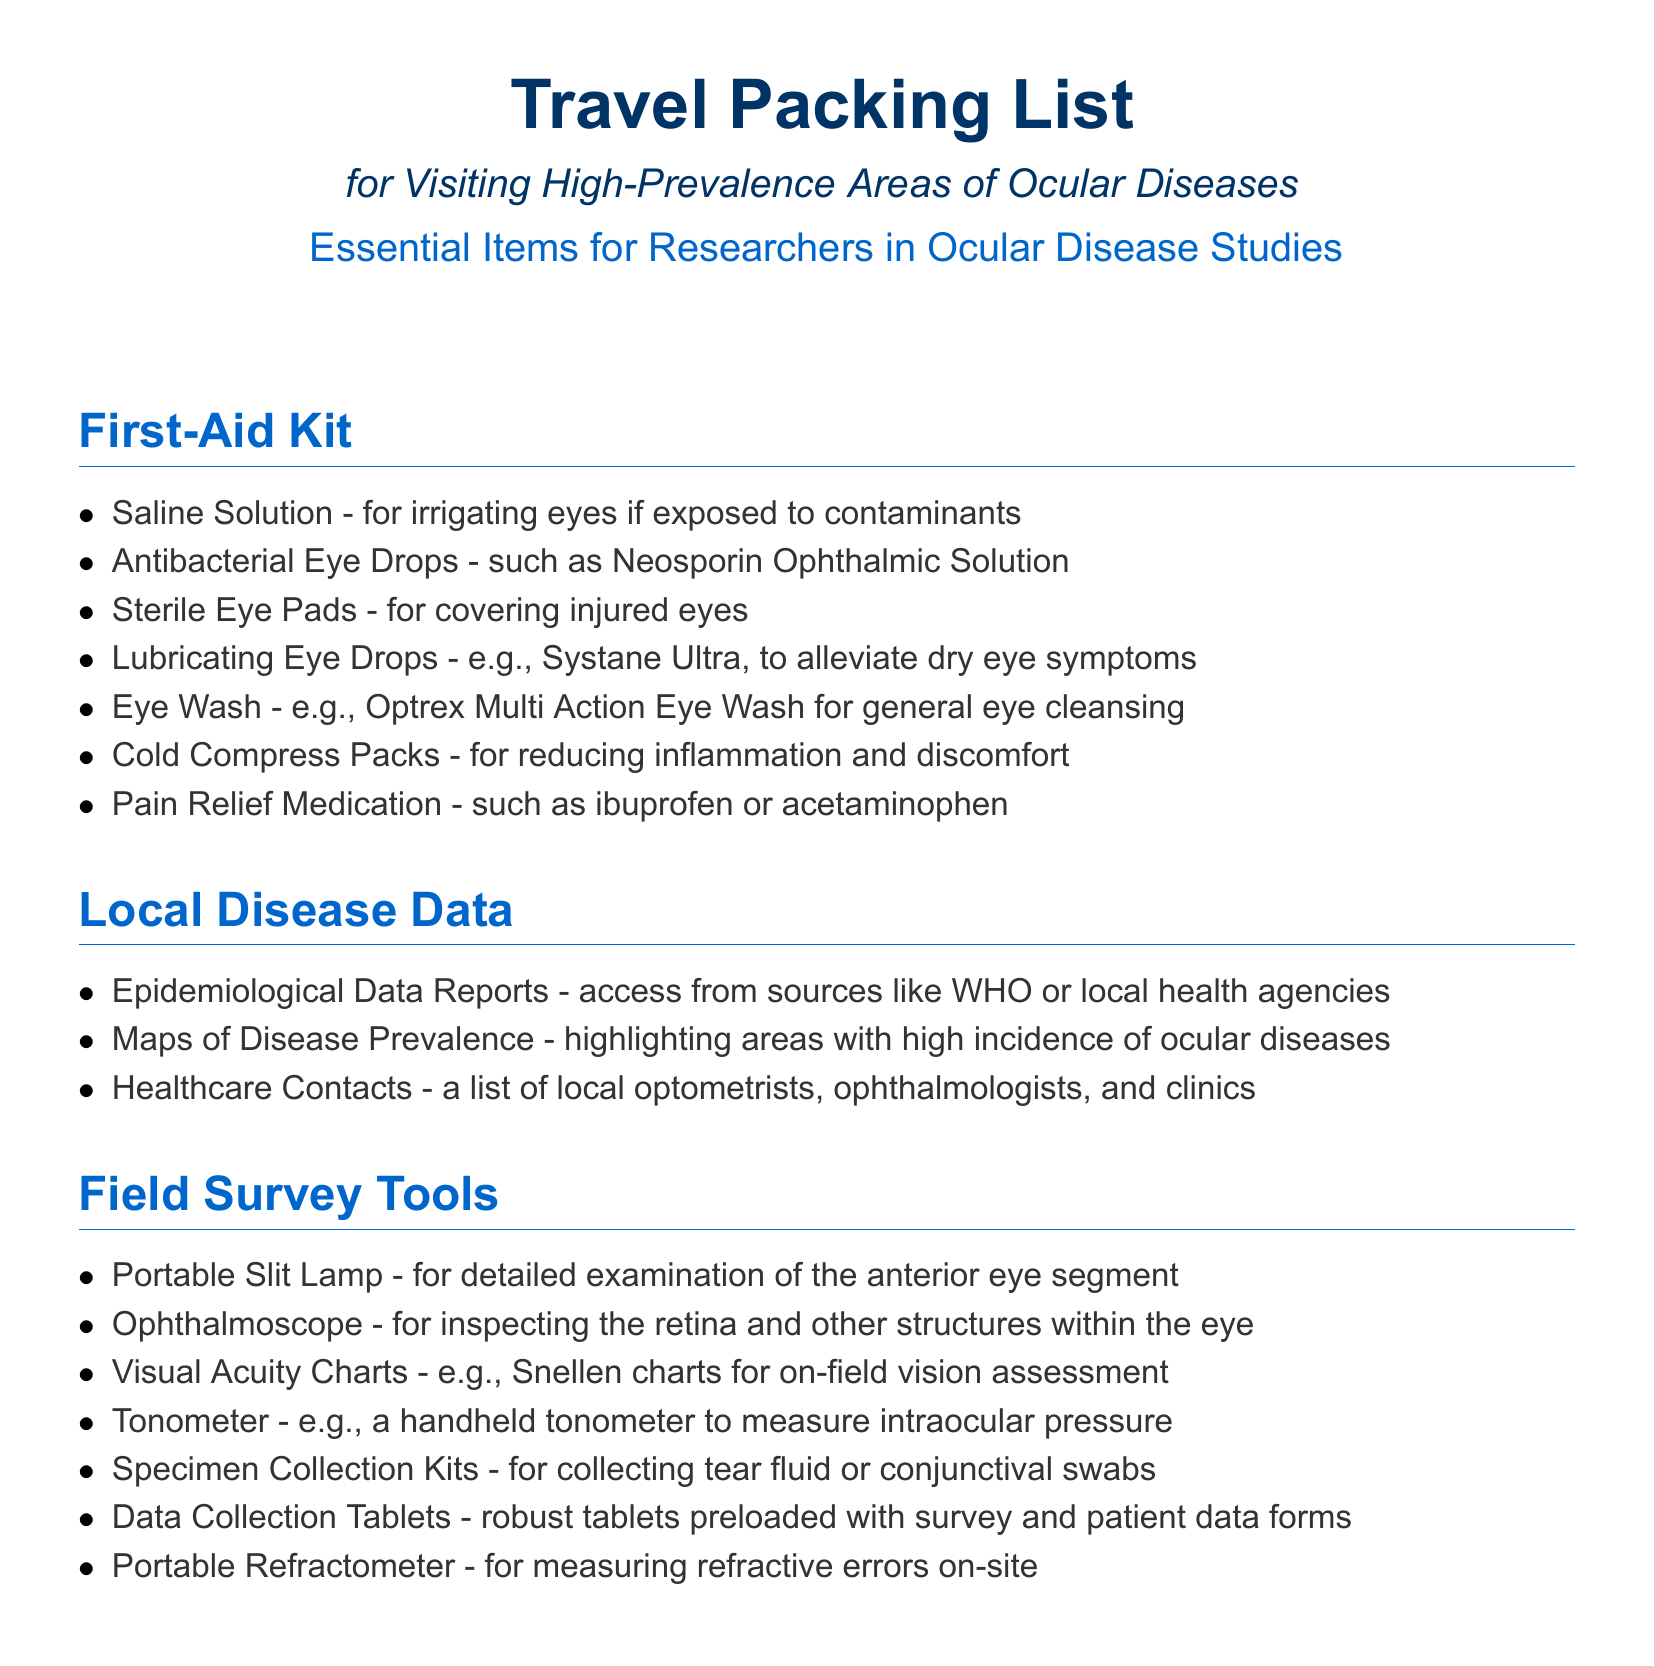what is one item included in the first-aid kit? The first-aid kit includes various items for eye care, such as saline solution, which can irrigate eyes if contaminants are present.
Answer: saline solution what type of data is listed under local disease data? The document specifies that epidemiological data reports should be accessed from organizations like WHO or local health agencies.
Answer: Epidemiological Data Reports how many types of field survey tools are listed? There are seven different field survey tools mentioned for ocular diseases.
Answer: seven which medical device is used for inspecting the retina? The document lists an ophthalmoscope as the device used for inspecting the retina and other internal structures of the eye.
Answer: Ophthalmoscope what is a portable tool used for measuring intraocular pressure? The document identifies a tonometer, specifically a handheld tonometer, for measuring intraocular pressure.
Answer: Tonometer what is the purpose of lubricating eye drops in the first-aid kit? Lubricating eye drops are mentioned in the first-aid kit to alleviate symptoms of dry eye.
Answer: alleviate dry eye symptoms name one document type that lists healthcare contacts. The local disease data includes healthcare contacts of local optometrists, ophthalmologists, and clinics.
Answer: Healthcare Contacts which item helps reduce inflammation and discomfort? Cold compress packs are listed as items that help reduce inflammation and discomfort in the first-aid kit.
Answer: Cold Compress Packs 